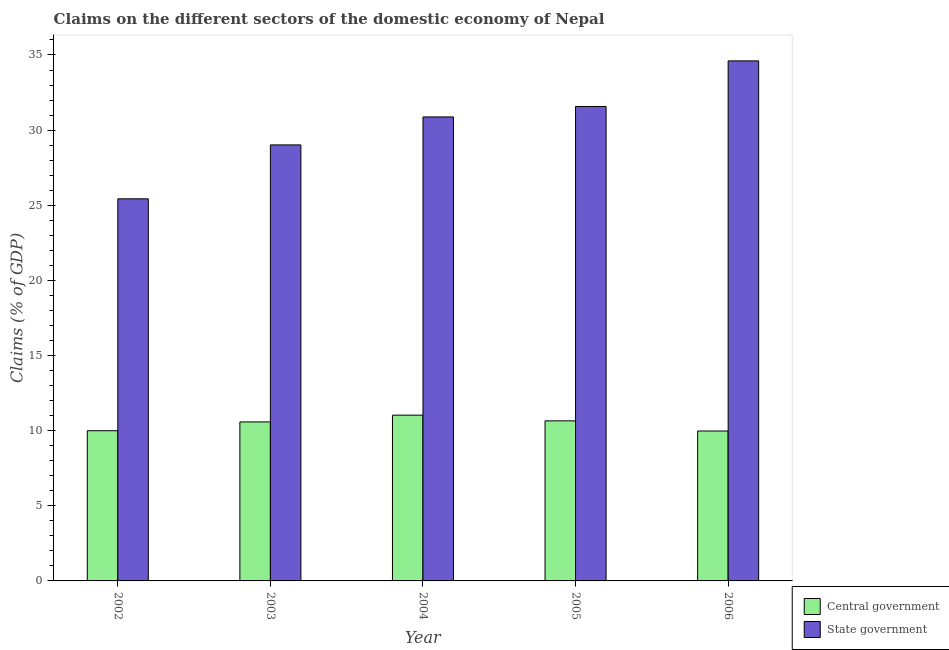How many different coloured bars are there?
Make the answer very short. 2. How many groups of bars are there?
Provide a short and direct response. 5. Are the number of bars per tick equal to the number of legend labels?
Your answer should be compact. Yes. Are the number of bars on each tick of the X-axis equal?
Ensure brevity in your answer.  Yes. What is the label of the 1st group of bars from the left?
Offer a terse response. 2002. In how many cases, is the number of bars for a given year not equal to the number of legend labels?
Your answer should be very brief. 0. What is the claims on central government in 2003?
Provide a short and direct response. 10.58. Across all years, what is the maximum claims on central government?
Provide a succinct answer. 11.03. Across all years, what is the minimum claims on state government?
Make the answer very short. 25.43. In which year was the claims on central government maximum?
Your answer should be compact. 2004. What is the total claims on state government in the graph?
Give a very brief answer. 151.5. What is the difference between the claims on state government in 2005 and that in 2006?
Your answer should be very brief. -3.03. What is the difference between the claims on central government in 2005 and the claims on state government in 2002?
Offer a very short reply. 0.66. What is the average claims on state government per year?
Provide a succinct answer. 30.3. In the year 2005, what is the difference between the claims on state government and claims on central government?
Your answer should be very brief. 0. In how many years, is the claims on central government greater than 26 %?
Your answer should be compact. 0. What is the ratio of the claims on central government in 2003 to that in 2006?
Your response must be concise. 1.06. What is the difference between the highest and the second highest claims on state government?
Offer a very short reply. 3.03. What is the difference between the highest and the lowest claims on central government?
Your answer should be very brief. 1.06. In how many years, is the claims on state government greater than the average claims on state government taken over all years?
Provide a succinct answer. 3. Is the sum of the claims on state government in 2003 and 2005 greater than the maximum claims on central government across all years?
Your answer should be very brief. Yes. What does the 2nd bar from the left in 2004 represents?
Your response must be concise. State government. What does the 1st bar from the right in 2006 represents?
Make the answer very short. State government. Are all the bars in the graph horizontal?
Your answer should be very brief. No. How many years are there in the graph?
Offer a very short reply. 5. Are the values on the major ticks of Y-axis written in scientific E-notation?
Give a very brief answer. No. Does the graph contain any zero values?
Your answer should be compact. No. Does the graph contain grids?
Offer a very short reply. No. How many legend labels are there?
Ensure brevity in your answer.  2. How are the legend labels stacked?
Your answer should be compact. Vertical. What is the title of the graph?
Give a very brief answer. Claims on the different sectors of the domestic economy of Nepal. Does "Non-residents" appear as one of the legend labels in the graph?
Your response must be concise. No. What is the label or title of the X-axis?
Keep it short and to the point. Year. What is the label or title of the Y-axis?
Give a very brief answer. Claims (% of GDP). What is the Claims (% of GDP) of Central government in 2002?
Your response must be concise. 10. What is the Claims (% of GDP) in State government in 2002?
Give a very brief answer. 25.43. What is the Claims (% of GDP) in Central government in 2003?
Offer a very short reply. 10.58. What is the Claims (% of GDP) in State government in 2003?
Your answer should be very brief. 29.01. What is the Claims (% of GDP) of Central government in 2004?
Provide a short and direct response. 11.03. What is the Claims (% of GDP) in State government in 2004?
Make the answer very short. 30.88. What is the Claims (% of GDP) in Central government in 2005?
Keep it short and to the point. 10.65. What is the Claims (% of GDP) in State government in 2005?
Offer a very short reply. 31.57. What is the Claims (% of GDP) of Central government in 2006?
Your answer should be very brief. 9.98. What is the Claims (% of GDP) in State government in 2006?
Your answer should be very brief. 34.61. Across all years, what is the maximum Claims (% of GDP) in Central government?
Make the answer very short. 11.03. Across all years, what is the maximum Claims (% of GDP) of State government?
Offer a very short reply. 34.61. Across all years, what is the minimum Claims (% of GDP) of Central government?
Give a very brief answer. 9.98. Across all years, what is the minimum Claims (% of GDP) of State government?
Make the answer very short. 25.43. What is the total Claims (% of GDP) of Central government in the graph?
Your answer should be very brief. 52.24. What is the total Claims (% of GDP) of State government in the graph?
Provide a succinct answer. 151.5. What is the difference between the Claims (% of GDP) in Central government in 2002 and that in 2003?
Offer a very short reply. -0.59. What is the difference between the Claims (% of GDP) of State government in 2002 and that in 2003?
Your answer should be very brief. -3.59. What is the difference between the Claims (% of GDP) in Central government in 2002 and that in 2004?
Keep it short and to the point. -1.04. What is the difference between the Claims (% of GDP) in State government in 2002 and that in 2004?
Keep it short and to the point. -5.45. What is the difference between the Claims (% of GDP) of Central government in 2002 and that in 2005?
Provide a short and direct response. -0.66. What is the difference between the Claims (% of GDP) of State government in 2002 and that in 2005?
Your response must be concise. -6.14. What is the difference between the Claims (% of GDP) of Central government in 2002 and that in 2006?
Ensure brevity in your answer.  0.02. What is the difference between the Claims (% of GDP) of State government in 2002 and that in 2006?
Offer a terse response. -9.18. What is the difference between the Claims (% of GDP) of Central government in 2003 and that in 2004?
Offer a terse response. -0.45. What is the difference between the Claims (% of GDP) in State government in 2003 and that in 2004?
Provide a short and direct response. -1.86. What is the difference between the Claims (% of GDP) in Central government in 2003 and that in 2005?
Give a very brief answer. -0.07. What is the difference between the Claims (% of GDP) in State government in 2003 and that in 2005?
Your answer should be compact. -2.56. What is the difference between the Claims (% of GDP) of Central government in 2003 and that in 2006?
Ensure brevity in your answer.  0.61. What is the difference between the Claims (% of GDP) in State government in 2003 and that in 2006?
Keep it short and to the point. -5.59. What is the difference between the Claims (% of GDP) of Central government in 2004 and that in 2005?
Your answer should be very brief. 0.38. What is the difference between the Claims (% of GDP) in State government in 2004 and that in 2005?
Ensure brevity in your answer.  -0.7. What is the difference between the Claims (% of GDP) in Central government in 2004 and that in 2006?
Your answer should be very brief. 1.06. What is the difference between the Claims (% of GDP) of State government in 2004 and that in 2006?
Make the answer very short. -3.73. What is the difference between the Claims (% of GDP) in Central government in 2005 and that in 2006?
Ensure brevity in your answer.  0.68. What is the difference between the Claims (% of GDP) of State government in 2005 and that in 2006?
Your response must be concise. -3.03. What is the difference between the Claims (% of GDP) in Central government in 2002 and the Claims (% of GDP) in State government in 2003?
Your answer should be very brief. -19.02. What is the difference between the Claims (% of GDP) in Central government in 2002 and the Claims (% of GDP) in State government in 2004?
Your answer should be very brief. -20.88. What is the difference between the Claims (% of GDP) in Central government in 2002 and the Claims (% of GDP) in State government in 2005?
Make the answer very short. -21.58. What is the difference between the Claims (% of GDP) in Central government in 2002 and the Claims (% of GDP) in State government in 2006?
Your answer should be compact. -24.61. What is the difference between the Claims (% of GDP) of Central government in 2003 and the Claims (% of GDP) of State government in 2004?
Offer a very short reply. -20.3. What is the difference between the Claims (% of GDP) in Central government in 2003 and the Claims (% of GDP) in State government in 2005?
Your answer should be compact. -20.99. What is the difference between the Claims (% of GDP) of Central government in 2003 and the Claims (% of GDP) of State government in 2006?
Offer a terse response. -24.03. What is the difference between the Claims (% of GDP) of Central government in 2004 and the Claims (% of GDP) of State government in 2005?
Ensure brevity in your answer.  -20.54. What is the difference between the Claims (% of GDP) of Central government in 2004 and the Claims (% of GDP) of State government in 2006?
Keep it short and to the point. -23.58. What is the difference between the Claims (% of GDP) of Central government in 2005 and the Claims (% of GDP) of State government in 2006?
Offer a terse response. -23.95. What is the average Claims (% of GDP) in Central government per year?
Give a very brief answer. 10.45. What is the average Claims (% of GDP) in State government per year?
Offer a very short reply. 30.3. In the year 2002, what is the difference between the Claims (% of GDP) of Central government and Claims (% of GDP) of State government?
Offer a very short reply. -15.43. In the year 2003, what is the difference between the Claims (% of GDP) in Central government and Claims (% of GDP) in State government?
Ensure brevity in your answer.  -18.43. In the year 2004, what is the difference between the Claims (% of GDP) in Central government and Claims (% of GDP) in State government?
Offer a terse response. -19.85. In the year 2005, what is the difference between the Claims (% of GDP) in Central government and Claims (% of GDP) in State government?
Ensure brevity in your answer.  -20.92. In the year 2006, what is the difference between the Claims (% of GDP) of Central government and Claims (% of GDP) of State government?
Keep it short and to the point. -24.63. What is the ratio of the Claims (% of GDP) of Central government in 2002 to that in 2003?
Your answer should be very brief. 0.94. What is the ratio of the Claims (% of GDP) in State government in 2002 to that in 2003?
Give a very brief answer. 0.88. What is the ratio of the Claims (% of GDP) of Central government in 2002 to that in 2004?
Provide a succinct answer. 0.91. What is the ratio of the Claims (% of GDP) of State government in 2002 to that in 2004?
Provide a short and direct response. 0.82. What is the ratio of the Claims (% of GDP) of Central government in 2002 to that in 2005?
Offer a terse response. 0.94. What is the ratio of the Claims (% of GDP) in State government in 2002 to that in 2005?
Your response must be concise. 0.81. What is the ratio of the Claims (% of GDP) in Central government in 2002 to that in 2006?
Your response must be concise. 1. What is the ratio of the Claims (% of GDP) of State government in 2002 to that in 2006?
Make the answer very short. 0.73. What is the ratio of the Claims (% of GDP) of Central government in 2003 to that in 2004?
Give a very brief answer. 0.96. What is the ratio of the Claims (% of GDP) in State government in 2003 to that in 2004?
Keep it short and to the point. 0.94. What is the ratio of the Claims (% of GDP) of Central government in 2003 to that in 2005?
Keep it short and to the point. 0.99. What is the ratio of the Claims (% of GDP) in State government in 2003 to that in 2005?
Ensure brevity in your answer.  0.92. What is the ratio of the Claims (% of GDP) of Central government in 2003 to that in 2006?
Offer a very short reply. 1.06. What is the ratio of the Claims (% of GDP) in State government in 2003 to that in 2006?
Your answer should be very brief. 0.84. What is the ratio of the Claims (% of GDP) of Central government in 2004 to that in 2005?
Provide a short and direct response. 1.04. What is the ratio of the Claims (% of GDP) of Central government in 2004 to that in 2006?
Your answer should be very brief. 1.11. What is the ratio of the Claims (% of GDP) in State government in 2004 to that in 2006?
Ensure brevity in your answer.  0.89. What is the ratio of the Claims (% of GDP) in Central government in 2005 to that in 2006?
Provide a short and direct response. 1.07. What is the ratio of the Claims (% of GDP) of State government in 2005 to that in 2006?
Provide a succinct answer. 0.91. What is the difference between the highest and the second highest Claims (% of GDP) of Central government?
Provide a succinct answer. 0.38. What is the difference between the highest and the second highest Claims (% of GDP) in State government?
Offer a very short reply. 3.03. What is the difference between the highest and the lowest Claims (% of GDP) in Central government?
Provide a short and direct response. 1.06. What is the difference between the highest and the lowest Claims (% of GDP) of State government?
Keep it short and to the point. 9.18. 